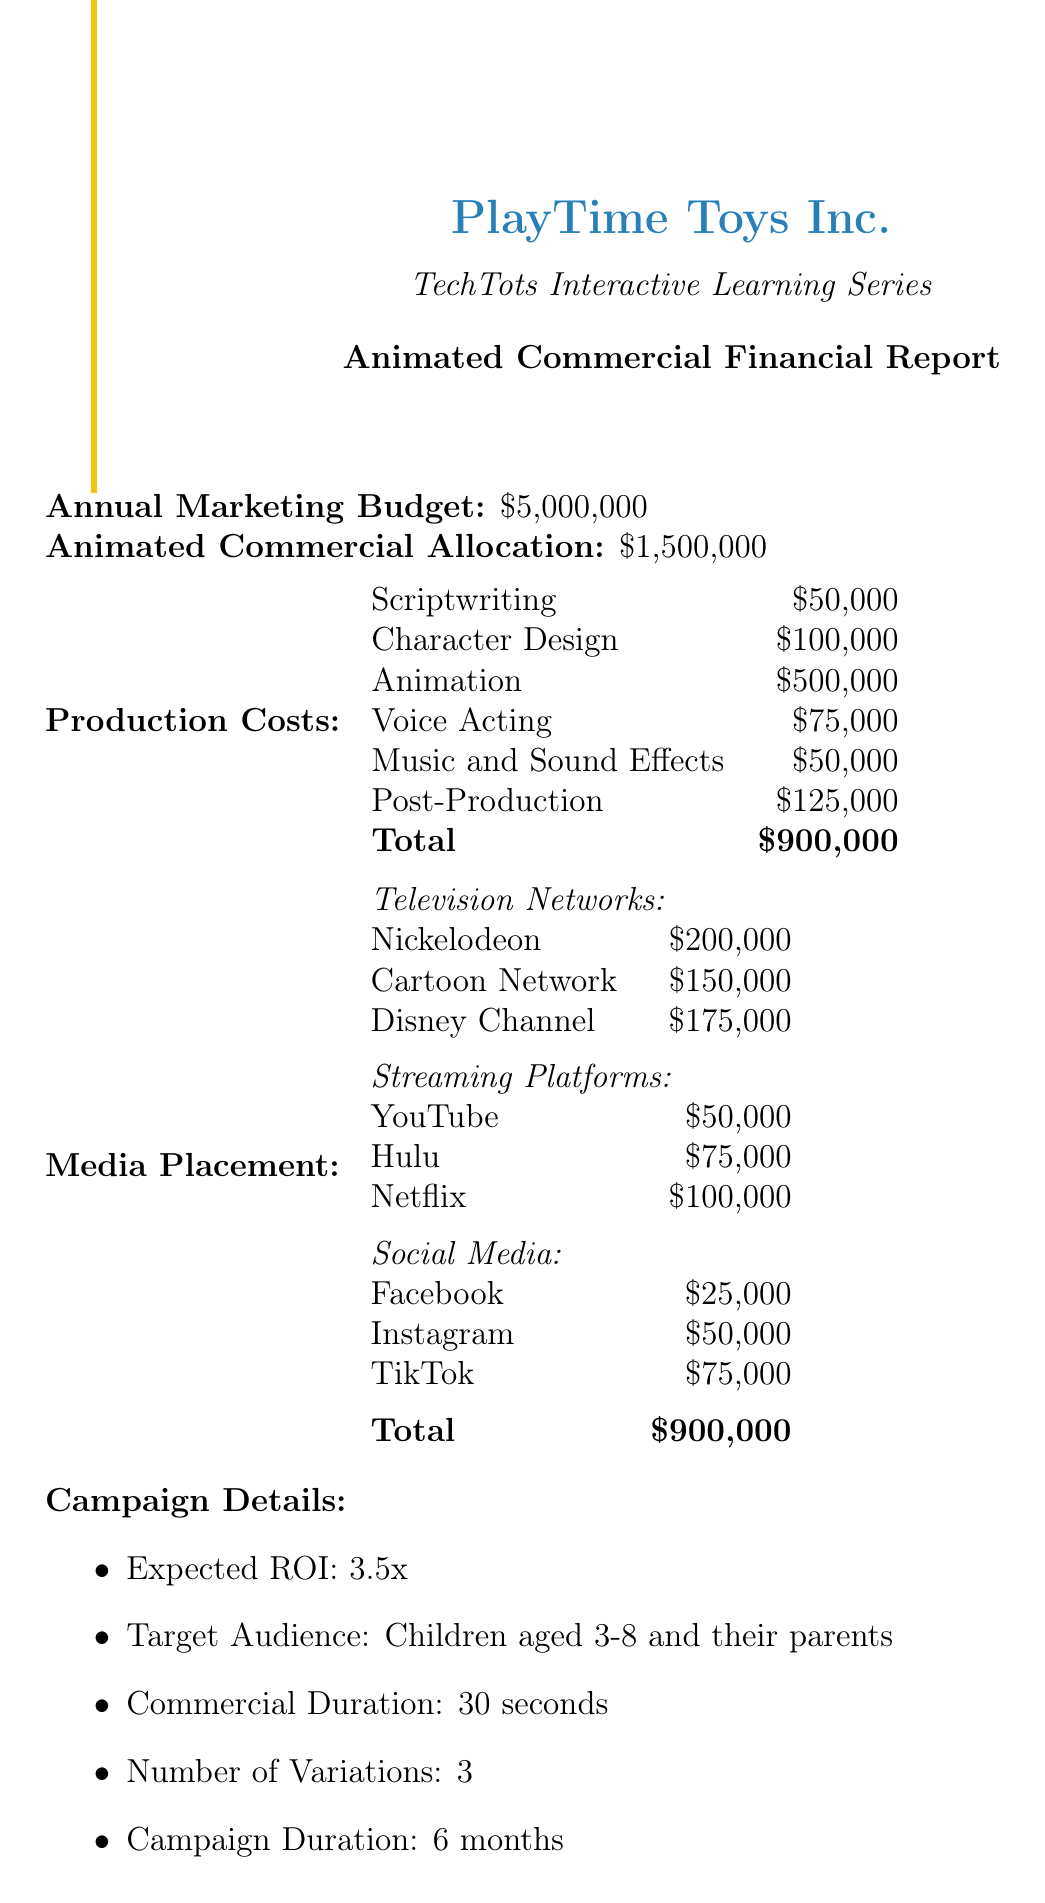What is the annual marketing budget? The annual marketing budget is explicitly stated in the document.
Answer: $5,000,000 How much is allocated for animated commercials? The document specifies the amount allocated for animated commercials.
Answer: $1,500,000 What is the total for production costs? The total production costs are listed in the breakdown section of the document.
Answer: $900,000 Which television network receives the highest allocation? The allocations for television networks are compared in the document to identify the highest one.
Answer: Nickelodeon What is the expected ROI for the campaign? The expected ROI is mentioned in the campaign details section of the document.
Answer: 3.5x How long is the commercial duration? The duration of the commercial is noted in the campaign details section.
Answer: 30 seconds What is the target audience for the animated commercials? The target audience is clearly stated in the document.
Answer: Children aged 3-8 and their parents How many variations of the commercial will be produced? The number of variations is specified in the campaign details.
Answer: 3 What are the total media placement costs? The total media placement costs are presented in the breakdown section of the document.
Answer: $900,000 